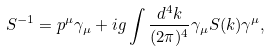Convert formula to latex. <formula><loc_0><loc_0><loc_500><loc_500>S ^ { - 1 } = p ^ { \mu } \gamma _ { \mu } + i g \int \frac { d ^ { 4 } k } { ( 2 \pi ) ^ { 4 } } \gamma _ { \mu } S ( k ) \gamma ^ { \mu } ,</formula> 